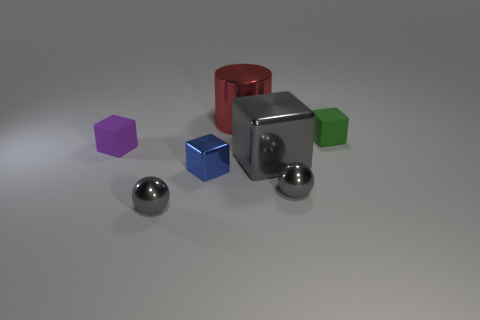Do the purple block and the large object that is behind the green thing have the same material?
Make the answer very short. No. Is the number of small blue objects behind the small purple matte block greater than the number of small rubber objects that are on the left side of the green thing?
Provide a succinct answer. No. There is a rubber object that is behind the tiny rubber object that is on the left side of the big red cylinder; what color is it?
Keep it short and to the point. Green. How many cubes are rubber objects or yellow objects?
Offer a very short reply. 2. How many tiny objects are to the left of the small shiny block and behind the tiny blue shiny object?
Keep it short and to the point. 1. What is the color of the rubber cube that is to the left of the tiny green rubber block?
Offer a very short reply. Purple. What is the size of the cube that is made of the same material as the big gray object?
Offer a very short reply. Small. There is a gray metallic object that is on the left side of the large red metal cylinder; how many spheres are behind it?
Keep it short and to the point. 1. There is a big red object; what number of small rubber objects are on the left side of it?
Provide a short and direct response. 1. There is a rubber cube that is behind the matte cube in front of the rubber thing on the right side of the blue thing; what is its color?
Your response must be concise. Green. 